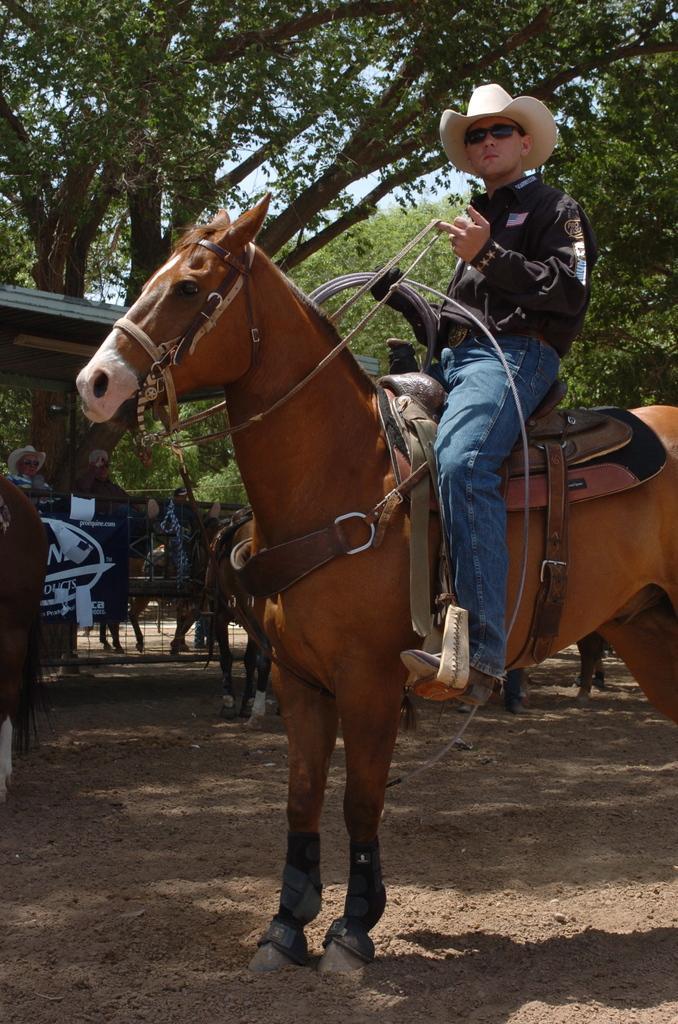In one or two sentences, can you explain what this image depicts? There is a horse. On the horse there is a saddle and a person is sitting. He is holding the rope and wearing a goggles and a cap. In the back there are horses, trees and people. 